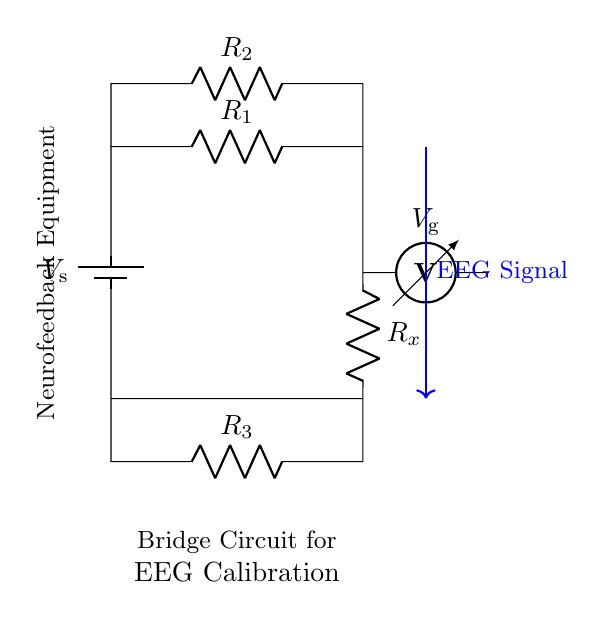What type of circuit is shown? The circuit displayed is a bridge circuit, specifically used for calibrating EEG equipment in neurofeedback treatments. It consists of resistors and a voltmeter, arranged in a balanced configuration.
Answer: bridge circuit What is the function of the voltmeter in this circuit? The voltmeter measures the voltage across the points connected to it (Vg), allowing the evaluation of the potential difference in the bridge circuit, which is essential for calibration in EEG.
Answer: measure voltage How many resistors are present in the circuit? There are three resistors in the circuit, labeled R1, R2, and R3, used for balancing the bridge and measuring resistance changes.
Answer: three What is the purpose of the battery in this circuit? The battery provides a constant voltage source (Vs), essential for powering the bridge circuit and enabling the measurement of voltage across the resistors.
Answer: power source Which component represents the EEG signal? The blue arrow labeled "EEG Signal" indicates that the connection represents the signal input from the EEG device into the bridge circuit for calibration.
Answer: EEG Signal How does the bridge circuit help in EEG calibration? The bridge circuit allows for precise measurement of resistance changes in the EEG equipment, facilitating accurate calibration by comparing the known resistance with the unknown (Rx). When balanced, it ensures proper signal readings.
Answer: precise measurement What does R_x represent in this circuit? R_x represents the unknown resistance or the specific resistance of the EEG electrodes being calibrated, which will be compared against the known resistors in the bridge for accuracy.
Answer: unknown resistance 